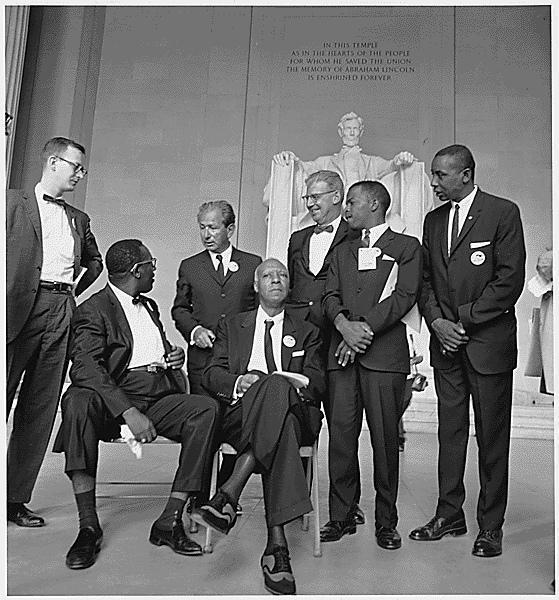How many men are in this picture?
Give a very brief answer. 7. How many people can be seen?
Give a very brief answer. 7. 